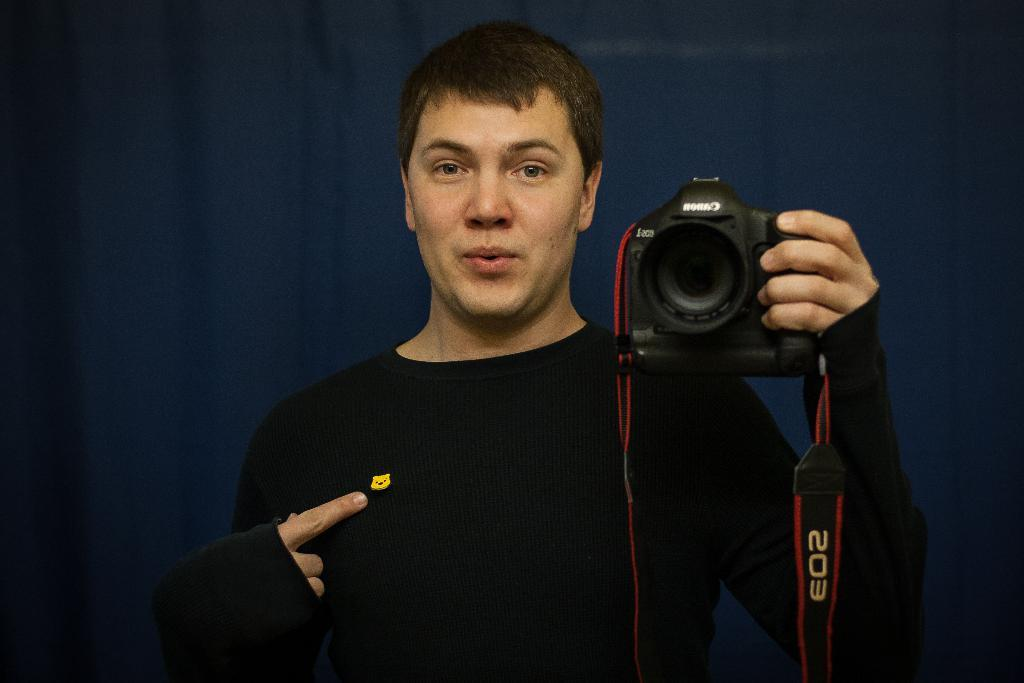Who is the main subject in the image? There is a man in the picture. What is the man wearing? The man is wearing a black t-shirt. What is the man holding in the image? The man is holding a camera. What color is the background of the image? The background of the image is blue. What type of plants can be seen growing in the market in the image? There is no market or plants present in the image; it features a man holding a camera with a blue background. 